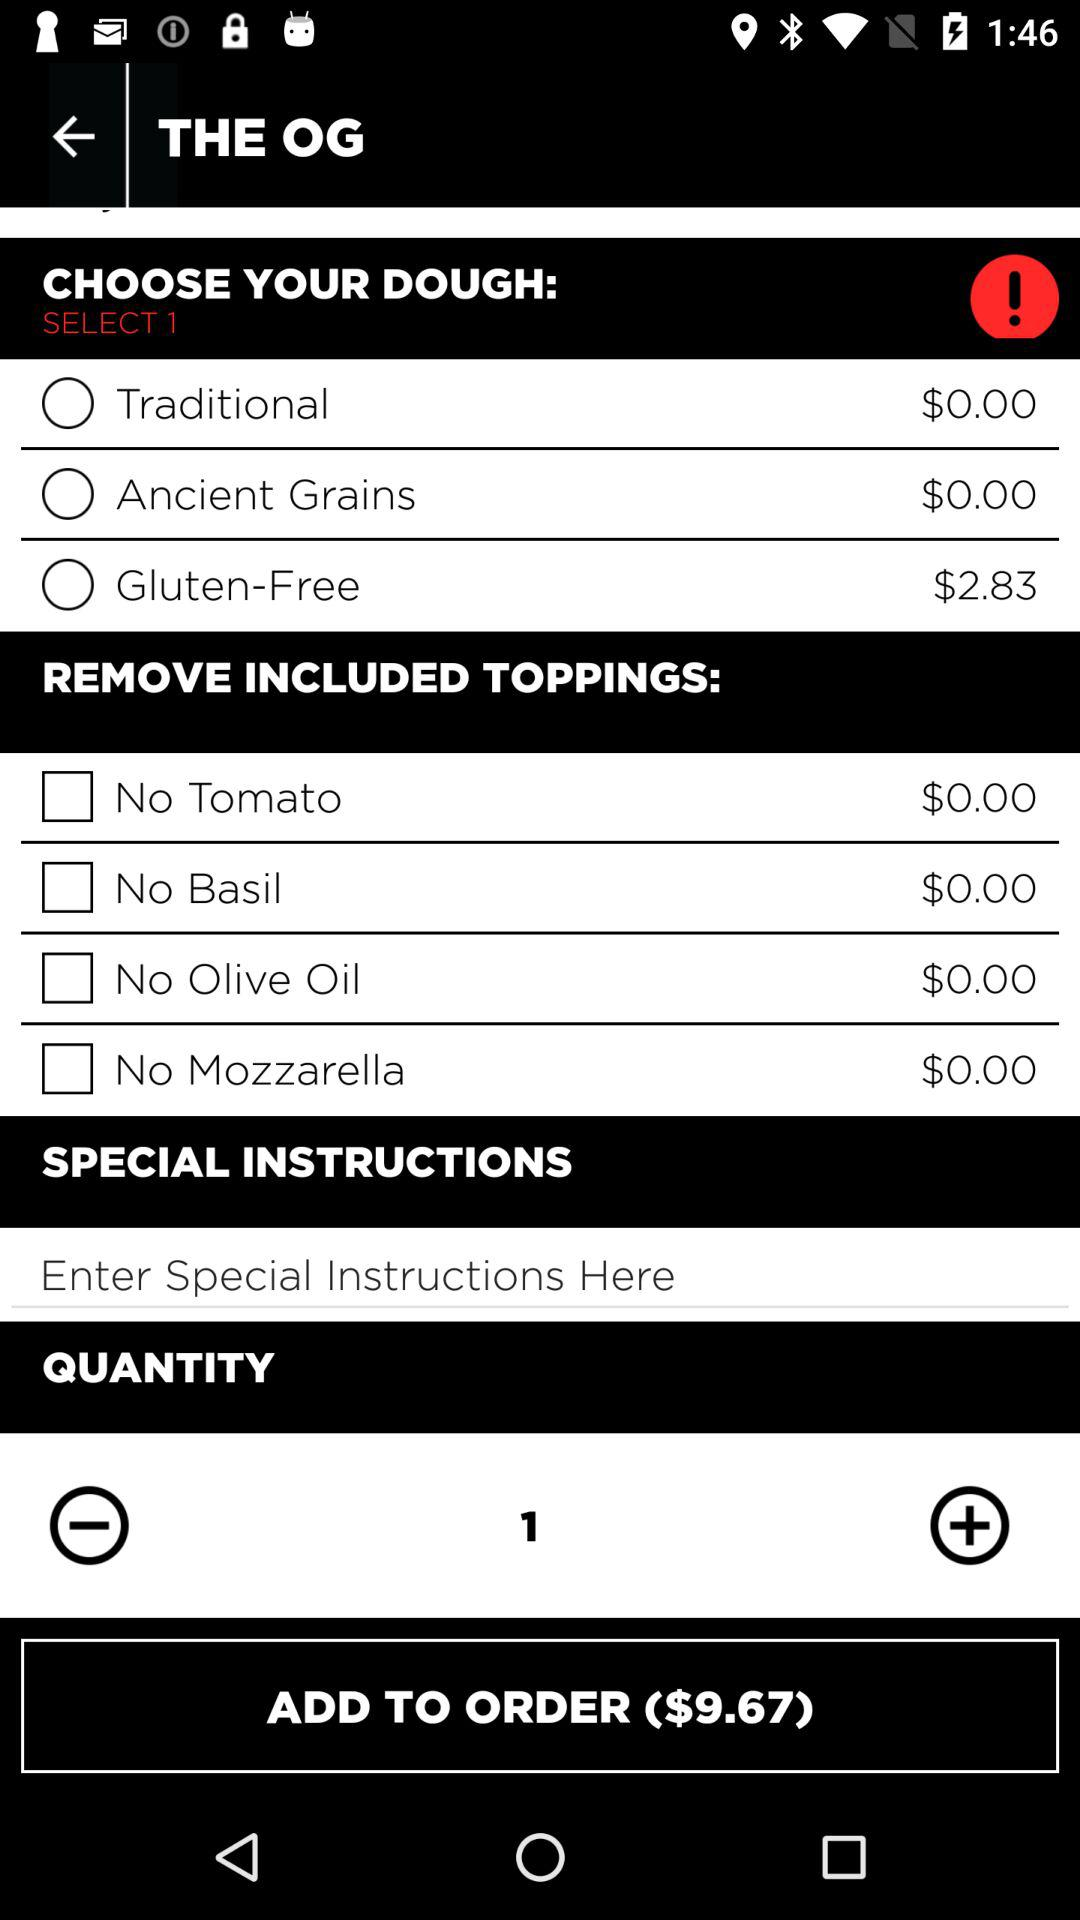How much does it cost to add something on the list?
When the provided information is insufficient, respond with <no answer>. <no answer> 